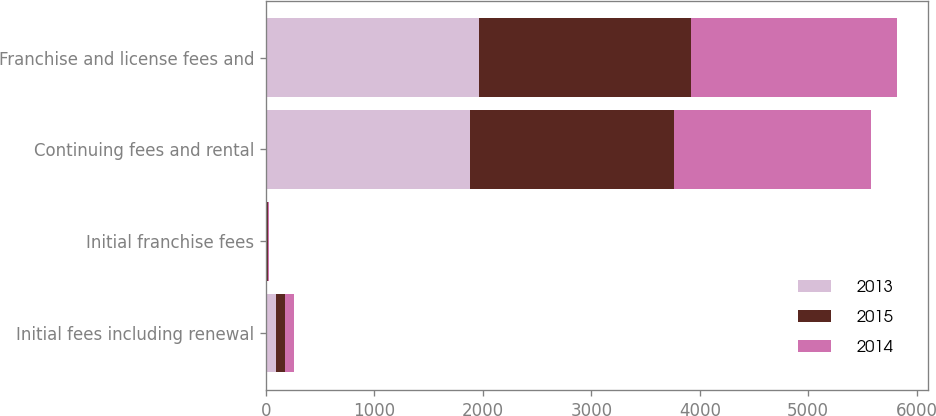Convert chart to OTSL. <chart><loc_0><loc_0><loc_500><loc_500><stacked_bar_chart><ecel><fcel>Initial fees including renewal<fcel>Initial franchise fees<fcel>Continuing fees and rental<fcel>Franchise and license fees and<nl><fcel>2013<fcel>88<fcel>10<fcel>1882<fcel>1960<nl><fcel>2015<fcel>83<fcel>5<fcel>1877<fcel>1955<nl><fcel>2014<fcel>90<fcel>13<fcel>1823<fcel>1900<nl></chart> 